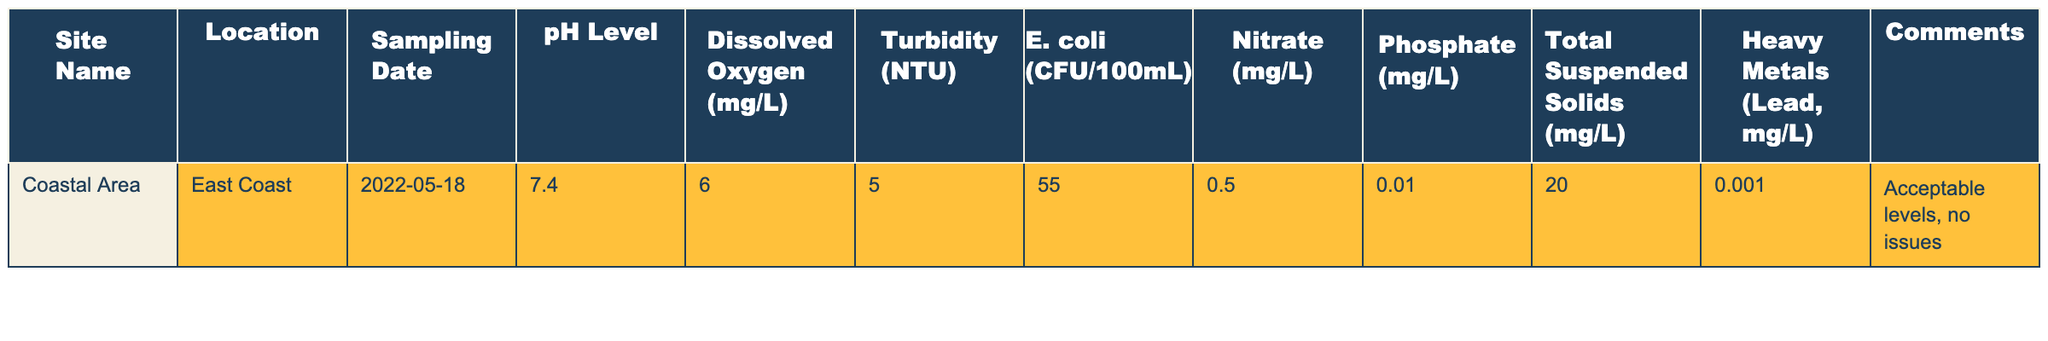What is the pH level recorded in the Coastal Area? The table lists the pH level for the Coastal Area as 7.4 under the “pH Level” column.
Answer: 7.4 What was the level of E. coli (CFU/100mL) found at the Coastal Area? The E. coli level recorded for the Coastal Area is 55, as noted in the “E. coli (CFU/100mL)” column of the table.
Answer: 55 Is the level of dissolved oxygen acceptable according to the data? The dissolved oxygen is reported as 6.0 mg/L, which is generally acceptable, and the comments state that the overall levels are acceptable with no issues.
Answer: Yes What is the nitrate level in the Coastal Area? The nitrate level recorded in the table for the Coastal Area is 0.5 mg/L, found in the “Nitrate (mg/L)” column.
Answer: 0.5 mg/L What is the turbidity level recorded in the Coastal Area? The table shows a turbidity level of 5.0 NTU for the Coastal Area, which can be found in the “Turbidity (NTU)” column.
Answer: 5.0 NTU Can you calculate the average of the pH level and dissolved oxygen? The pH level is 7.4 and the dissolved oxygen is 6.0. To find the average, add 7.4 and 6.0 to get 13.4, then divide by 2 which results in an average of 6.7.
Answer: 6.7 Based on the table, is the total suspended solids value above or below 25 mg/L? The total suspended solids value is 20 mg/L, which is below 25 mg/L. Therefore, based on the data, it is below 25 mg/L.
Answer: Below How many pollutants have levels exceeding 1 mg/L in the Coastal Area? The table indicates that there are no pollutants with levels exceeding 1 mg/L, as all measured values (nitrate, phosphate, and heavy metals) fall below this threshold.
Answer: 0 If combined, what is the total amount of dissolved oxygen and heavy metals for the Coastal Area? The dissolved oxygen is 6.0 mg/L and the heavy metals (lead) are at 0.001 mg/L. Adding these values gives a total of 6.0 + 0.001 = 6.001 mg/L.
Answer: 6.001 mg/L Are the phosphate levels in the Coastal Area below the threshold of 0.1 mg/L? The phosphate level recorded is 0.01 mg/L, which is indeed below the threshold of 0.1 mg/L as stated in the "Phosphate (mg/L)" column.
Answer: Yes 